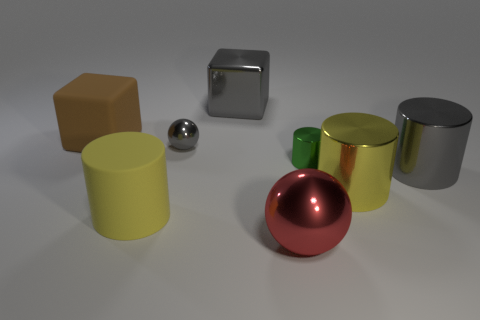Subtract all tiny metallic cylinders. How many cylinders are left? 3 Add 1 shiny blocks. How many objects exist? 9 Subtract all gray balls. How many balls are left? 1 Subtract all spheres. How many objects are left? 6 Add 2 small gray balls. How many small gray balls exist? 3 Subtract 0 cyan cylinders. How many objects are left? 8 Subtract 2 balls. How many balls are left? 0 Subtract all cyan cubes. Subtract all yellow cylinders. How many cubes are left? 2 Subtract all blue cylinders. How many gray blocks are left? 1 Subtract all tiny rubber cubes. Subtract all large red spheres. How many objects are left? 7 